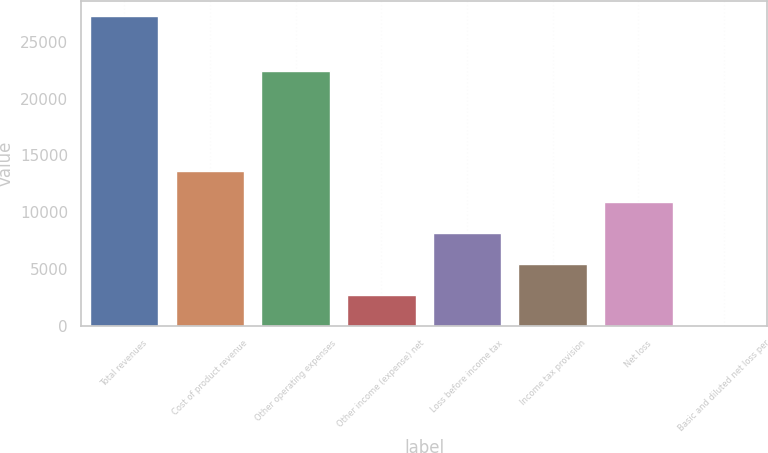<chart> <loc_0><loc_0><loc_500><loc_500><bar_chart><fcel>Total revenues<fcel>Cost of product revenue<fcel>Other operating expenses<fcel>Other income (expense) net<fcel>Loss before income tax<fcel>Income tax provision<fcel>Net loss<fcel>Basic and diluted net loss per<nl><fcel>27244<fcel>13622<fcel>22479<fcel>2724.42<fcel>8173.22<fcel>5448.82<fcel>10897.6<fcel>0.02<nl></chart> 